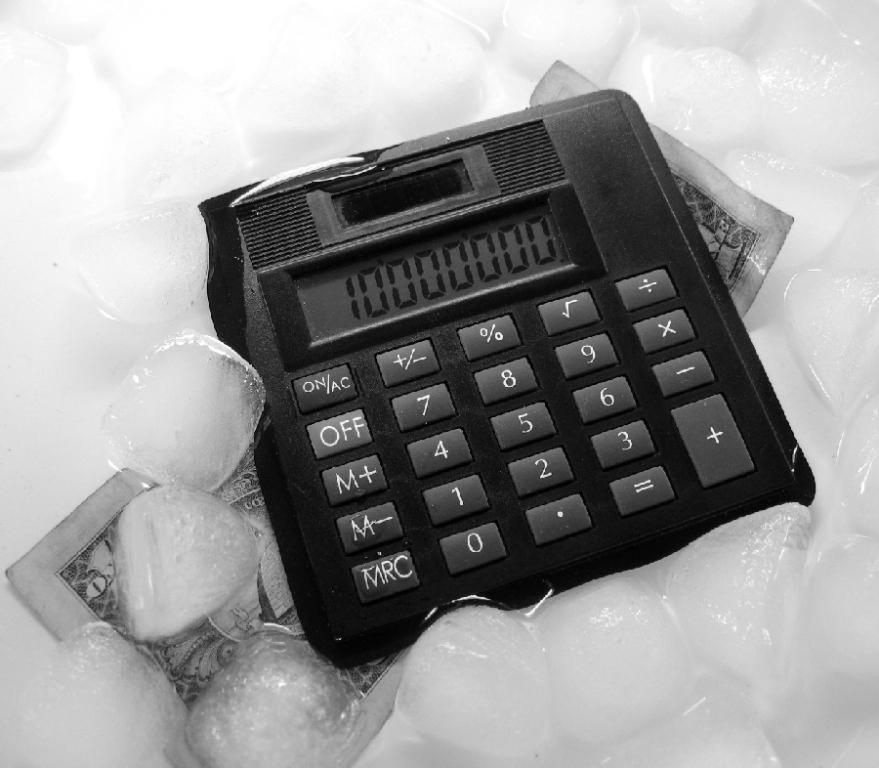<image>
Relay a brief, clear account of the picture shown. A calculator with a  number 1 with a bunch of  zeros,  on top of a bill and ice. 